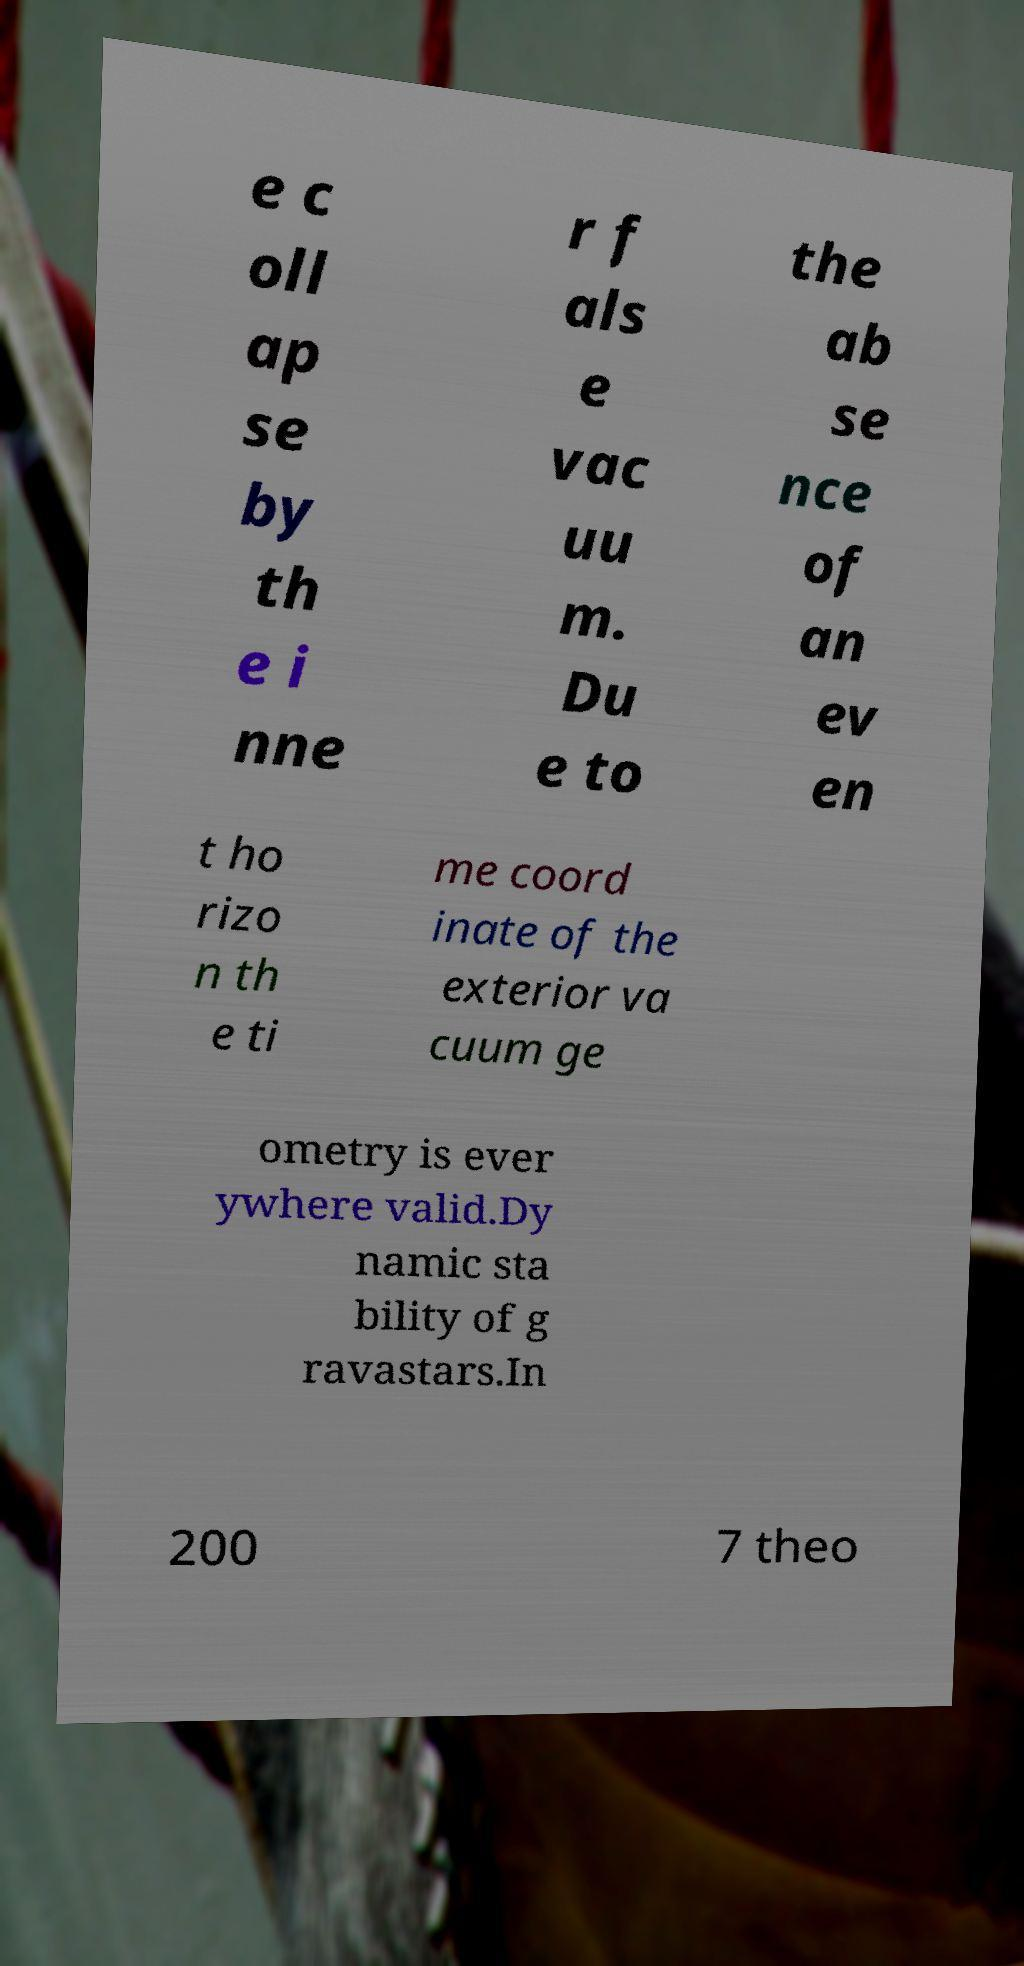Please read and relay the text visible in this image. What does it say? e c oll ap se by th e i nne r f als e vac uu m. Du e to the ab se nce of an ev en t ho rizo n th e ti me coord inate of the exterior va cuum ge ometry is ever ywhere valid.Dy namic sta bility of g ravastars.In 200 7 theo 